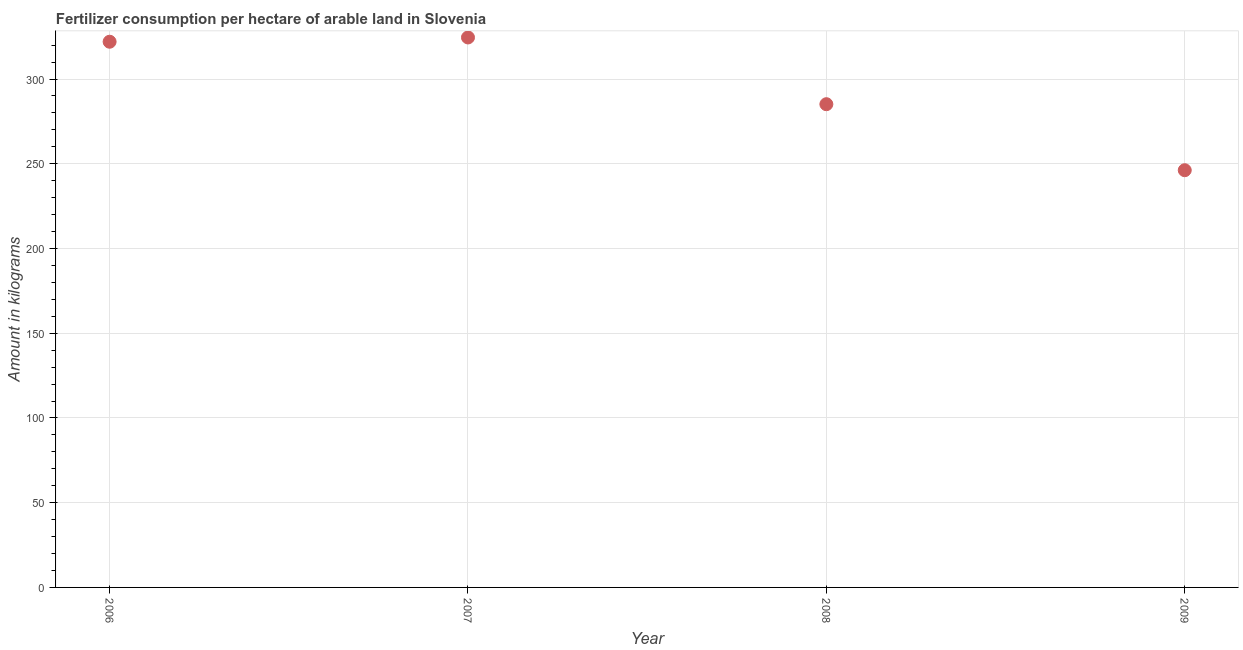What is the amount of fertilizer consumption in 2007?
Give a very brief answer. 324.53. Across all years, what is the maximum amount of fertilizer consumption?
Your answer should be compact. 324.53. Across all years, what is the minimum amount of fertilizer consumption?
Provide a succinct answer. 246.19. In which year was the amount of fertilizer consumption maximum?
Offer a very short reply. 2007. In which year was the amount of fertilizer consumption minimum?
Offer a very short reply. 2009. What is the sum of the amount of fertilizer consumption?
Your response must be concise. 1177.87. What is the difference between the amount of fertilizer consumption in 2006 and 2008?
Give a very brief answer. 36.86. What is the average amount of fertilizer consumption per year?
Provide a succinct answer. 294.47. What is the median amount of fertilizer consumption?
Provide a short and direct response. 303.58. In how many years, is the amount of fertilizer consumption greater than 150 kg?
Your answer should be very brief. 4. Do a majority of the years between 2007 and 2008 (inclusive) have amount of fertilizer consumption greater than 290 kg?
Your answer should be compact. No. What is the ratio of the amount of fertilizer consumption in 2006 to that in 2008?
Offer a terse response. 1.13. Is the difference between the amount of fertilizer consumption in 2006 and 2008 greater than the difference between any two years?
Your response must be concise. No. What is the difference between the highest and the second highest amount of fertilizer consumption?
Your answer should be compact. 2.52. Is the sum of the amount of fertilizer consumption in 2007 and 2008 greater than the maximum amount of fertilizer consumption across all years?
Keep it short and to the point. Yes. What is the difference between the highest and the lowest amount of fertilizer consumption?
Your answer should be compact. 78.33. In how many years, is the amount of fertilizer consumption greater than the average amount of fertilizer consumption taken over all years?
Your answer should be compact. 2. Does the amount of fertilizer consumption monotonically increase over the years?
Ensure brevity in your answer.  No. What is the title of the graph?
Provide a succinct answer. Fertilizer consumption per hectare of arable land in Slovenia . What is the label or title of the Y-axis?
Your answer should be compact. Amount in kilograms. What is the Amount in kilograms in 2006?
Your answer should be very brief. 322.01. What is the Amount in kilograms in 2007?
Offer a very short reply. 324.53. What is the Amount in kilograms in 2008?
Make the answer very short. 285.14. What is the Amount in kilograms in 2009?
Your response must be concise. 246.19. What is the difference between the Amount in kilograms in 2006 and 2007?
Provide a succinct answer. -2.52. What is the difference between the Amount in kilograms in 2006 and 2008?
Your response must be concise. 36.86. What is the difference between the Amount in kilograms in 2006 and 2009?
Make the answer very short. 75.81. What is the difference between the Amount in kilograms in 2007 and 2008?
Provide a short and direct response. 39.38. What is the difference between the Amount in kilograms in 2007 and 2009?
Provide a succinct answer. 78.33. What is the difference between the Amount in kilograms in 2008 and 2009?
Make the answer very short. 38.95. What is the ratio of the Amount in kilograms in 2006 to that in 2008?
Provide a short and direct response. 1.13. What is the ratio of the Amount in kilograms in 2006 to that in 2009?
Offer a terse response. 1.31. What is the ratio of the Amount in kilograms in 2007 to that in 2008?
Provide a short and direct response. 1.14. What is the ratio of the Amount in kilograms in 2007 to that in 2009?
Keep it short and to the point. 1.32. What is the ratio of the Amount in kilograms in 2008 to that in 2009?
Keep it short and to the point. 1.16. 